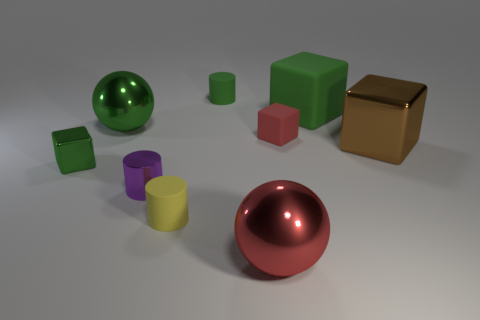What number of other things are there of the same size as the red metal object?
Make the answer very short. 3. Are there fewer big blue metal things than red blocks?
Provide a succinct answer. Yes. There is a big green metal thing; what shape is it?
Make the answer very short. Sphere. There is a tiny shiny object right of the green sphere; is it the same color as the tiny matte block?
Provide a succinct answer. No. What is the shape of the thing that is both in front of the small shiny block and right of the tiny yellow cylinder?
Provide a succinct answer. Sphere. What color is the rubber block that is left of the large rubber thing?
Keep it short and to the point. Red. Are there any other things that have the same color as the large matte object?
Make the answer very short. Yes. Is the size of the brown cube the same as the yellow matte object?
Your response must be concise. No. How big is the object that is right of the small red rubber thing and behind the small red object?
Give a very brief answer. Large. How many brown things have the same material as the small green cylinder?
Your answer should be very brief. 0. 